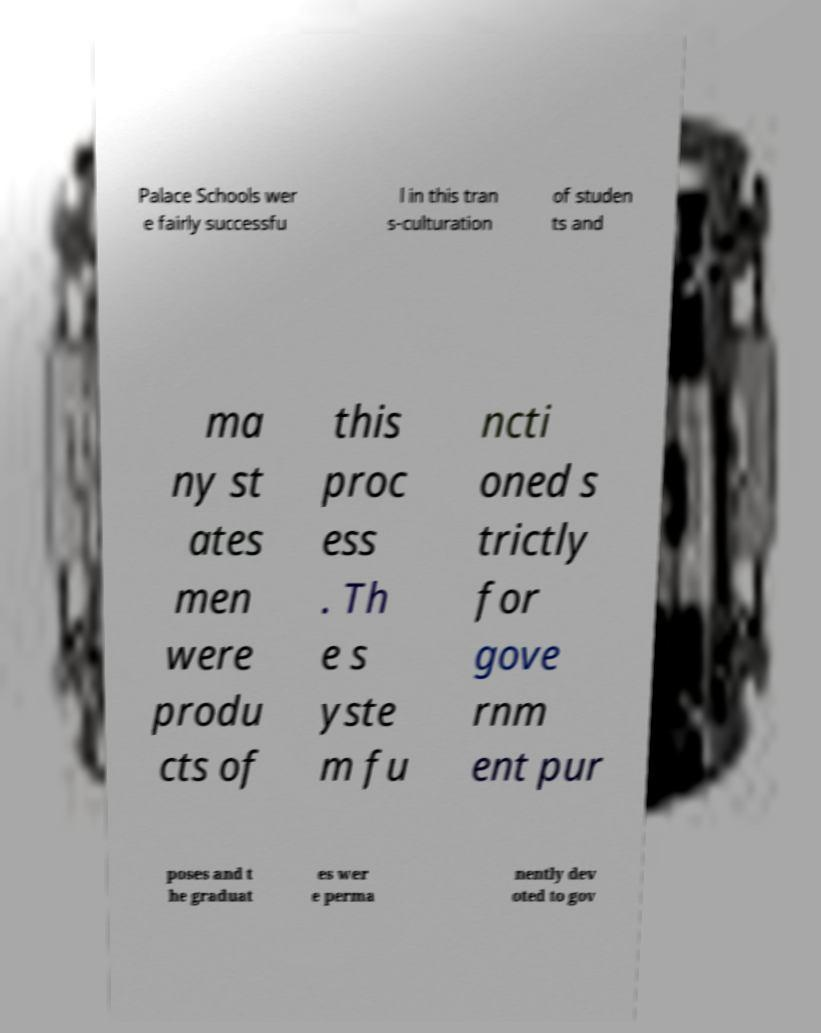I need the written content from this picture converted into text. Can you do that? Palace Schools wer e fairly successfu l in this tran s-culturation of studen ts and ma ny st ates men were produ cts of this proc ess . Th e s yste m fu ncti oned s trictly for gove rnm ent pur poses and t he graduat es wer e perma nently dev oted to gov 